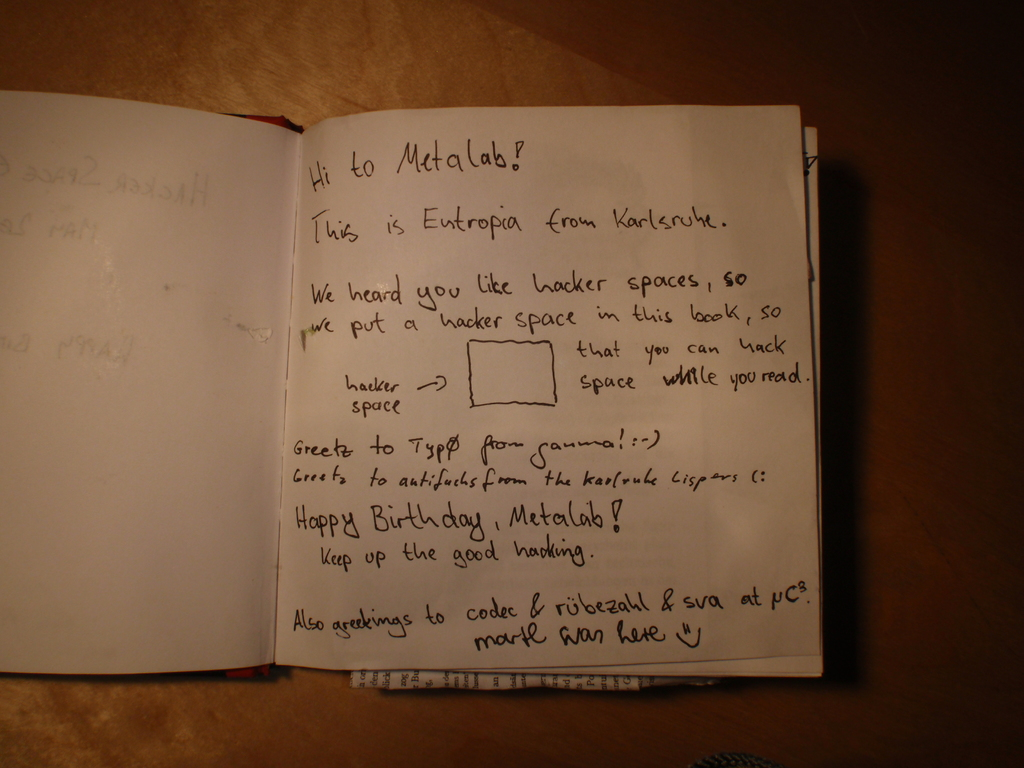Describe the following image.
 The image captures a heartfelt handwritten note from a group named "Entropia" to another group called "Metalab". The note, penned in black ink on a notebook, conveys Entropia's understanding of Metalab's fondness for hacker spaces. In a friendly gesture, Entropia offers to create such a space for Metalab. The note also carries a warm birthday wish for Metalab, applauding their work and encouraging them to continue their efforts. The message, though simple, reflects a sense of camaraderie and shared passion between the two groups. 